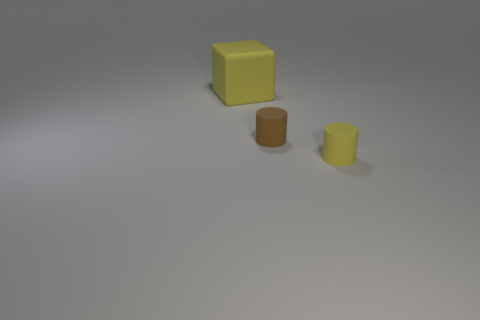Subtract all green blocks. Subtract all red spheres. How many blocks are left? 1 Add 1 gray matte blocks. How many objects exist? 4 Subtract all cylinders. How many objects are left? 1 Add 1 gray matte cubes. How many gray matte cubes exist? 1 Subtract 0 purple cubes. How many objects are left? 3 Subtract all yellow cubes. Subtract all large yellow matte things. How many objects are left? 1 Add 2 yellow cylinders. How many yellow cylinders are left? 3 